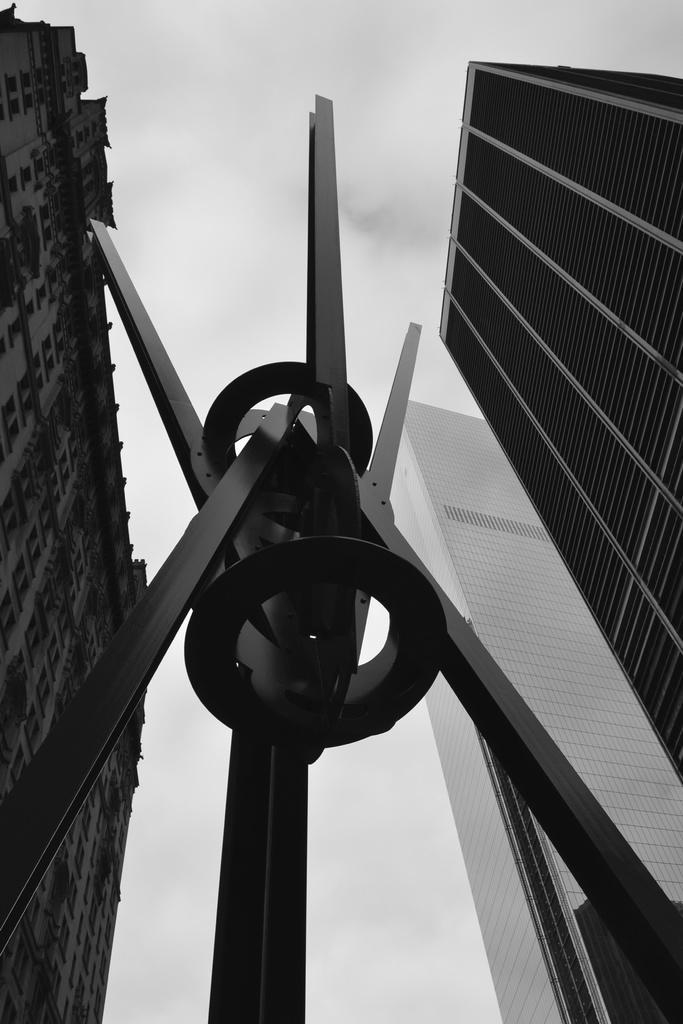Please provide a concise description of this image. In this image I can see the black and white picture in which I can see a black colored metal structure and few buildings. In the background I can see the sky. 